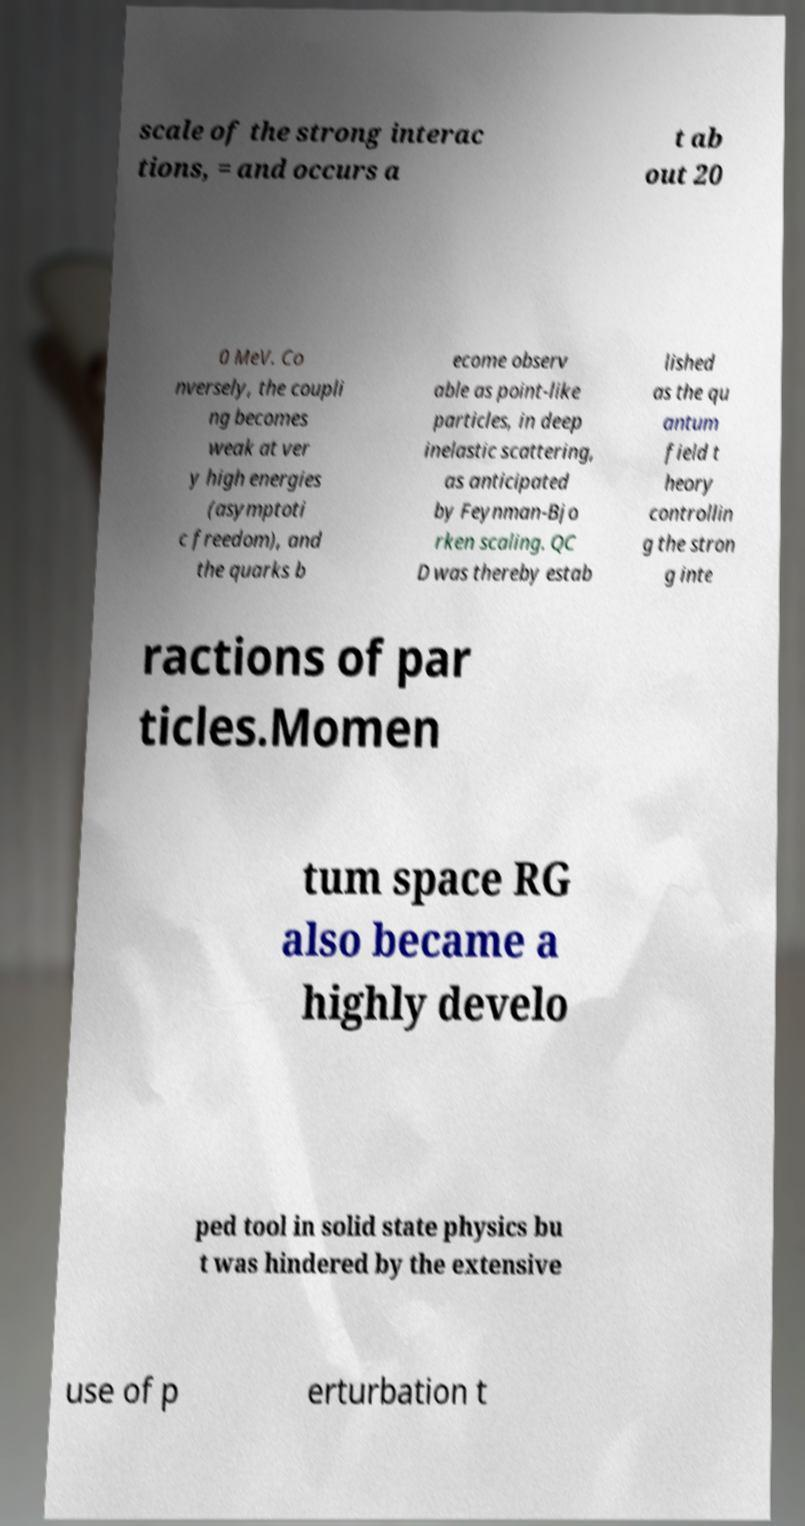Please identify and transcribe the text found in this image. scale of the strong interac tions, = and occurs a t ab out 20 0 MeV. Co nversely, the coupli ng becomes weak at ver y high energies (asymptoti c freedom), and the quarks b ecome observ able as point-like particles, in deep inelastic scattering, as anticipated by Feynman-Bjo rken scaling. QC D was thereby estab lished as the qu antum field t heory controllin g the stron g inte ractions of par ticles.Momen tum space RG also became a highly develo ped tool in solid state physics bu t was hindered by the extensive use of p erturbation t 